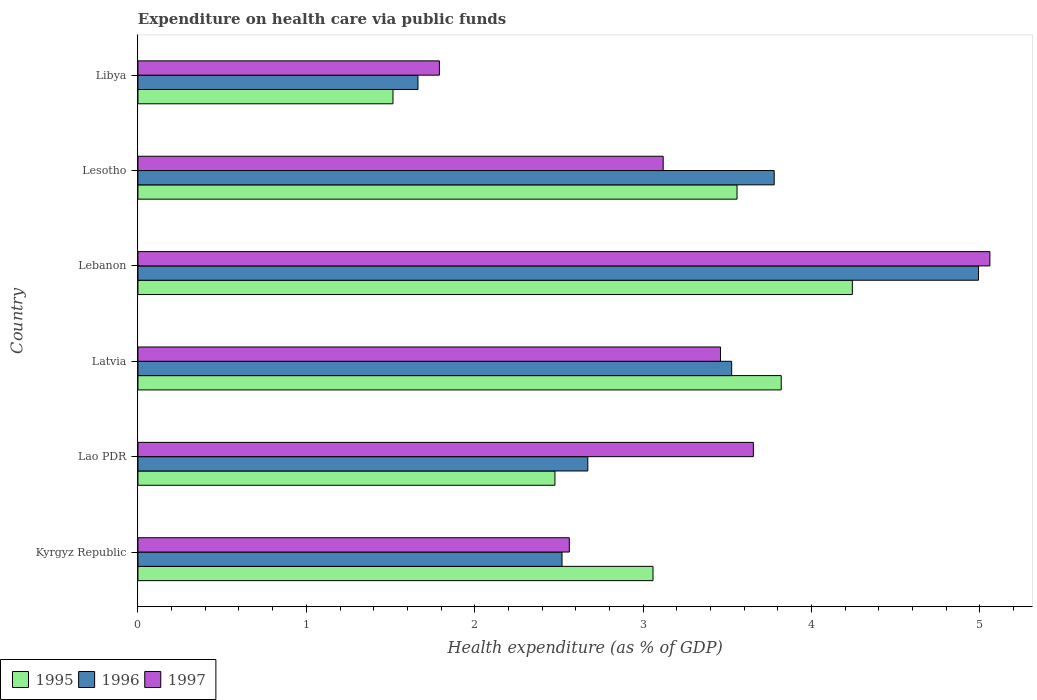How many groups of bars are there?
Offer a very short reply. 6. How many bars are there on the 3rd tick from the bottom?
Give a very brief answer. 3. What is the label of the 4th group of bars from the top?
Make the answer very short. Latvia. What is the expenditure made on health care in 1997 in Kyrgyz Republic?
Keep it short and to the point. 2.56. Across all countries, what is the maximum expenditure made on health care in 1997?
Keep it short and to the point. 5.06. Across all countries, what is the minimum expenditure made on health care in 1997?
Offer a terse response. 1.79. In which country was the expenditure made on health care in 1996 maximum?
Give a very brief answer. Lebanon. In which country was the expenditure made on health care in 1996 minimum?
Your answer should be compact. Libya. What is the total expenditure made on health care in 1995 in the graph?
Keep it short and to the point. 18.67. What is the difference between the expenditure made on health care in 1996 in Lao PDR and that in Latvia?
Your response must be concise. -0.85. What is the difference between the expenditure made on health care in 1997 in Lesotho and the expenditure made on health care in 1995 in Lebanon?
Provide a short and direct response. -1.12. What is the average expenditure made on health care in 1996 per country?
Keep it short and to the point. 3.19. What is the difference between the expenditure made on health care in 1995 and expenditure made on health care in 1996 in Lao PDR?
Offer a very short reply. -0.2. What is the ratio of the expenditure made on health care in 1997 in Kyrgyz Republic to that in Lesotho?
Keep it short and to the point. 0.82. Is the expenditure made on health care in 1997 in Lao PDR less than that in Lesotho?
Your answer should be compact. No. What is the difference between the highest and the second highest expenditure made on health care in 1997?
Ensure brevity in your answer.  1.4. What is the difference between the highest and the lowest expenditure made on health care in 1997?
Give a very brief answer. 3.27. In how many countries, is the expenditure made on health care in 1995 greater than the average expenditure made on health care in 1995 taken over all countries?
Offer a very short reply. 3. What does the 3rd bar from the top in Latvia represents?
Your answer should be very brief. 1995. What does the 1st bar from the bottom in Lebanon represents?
Your answer should be compact. 1995. Is it the case that in every country, the sum of the expenditure made on health care in 1995 and expenditure made on health care in 1997 is greater than the expenditure made on health care in 1996?
Your answer should be very brief. Yes. Are all the bars in the graph horizontal?
Make the answer very short. Yes. How many countries are there in the graph?
Keep it short and to the point. 6. Does the graph contain any zero values?
Your answer should be compact. No. Does the graph contain grids?
Your answer should be compact. No. How many legend labels are there?
Your answer should be compact. 3. How are the legend labels stacked?
Provide a succinct answer. Horizontal. What is the title of the graph?
Give a very brief answer. Expenditure on health care via public funds. What is the label or title of the X-axis?
Make the answer very short. Health expenditure (as % of GDP). What is the Health expenditure (as % of GDP) of 1995 in Kyrgyz Republic?
Keep it short and to the point. 3.06. What is the Health expenditure (as % of GDP) of 1996 in Kyrgyz Republic?
Your answer should be compact. 2.52. What is the Health expenditure (as % of GDP) of 1997 in Kyrgyz Republic?
Offer a very short reply. 2.56. What is the Health expenditure (as % of GDP) in 1995 in Lao PDR?
Offer a very short reply. 2.48. What is the Health expenditure (as % of GDP) in 1996 in Lao PDR?
Your answer should be compact. 2.67. What is the Health expenditure (as % of GDP) in 1997 in Lao PDR?
Offer a terse response. 3.65. What is the Health expenditure (as % of GDP) of 1995 in Latvia?
Offer a terse response. 3.82. What is the Health expenditure (as % of GDP) in 1996 in Latvia?
Give a very brief answer. 3.53. What is the Health expenditure (as % of GDP) in 1997 in Latvia?
Your response must be concise. 3.46. What is the Health expenditure (as % of GDP) of 1995 in Lebanon?
Your answer should be very brief. 4.24. What is the Health expenditure (as % of GDP) in 1996 in Lebanon?
Keep it short and to the point. 4.99. What is the Health expenditure (as % of GDP) in 1997 in Lebanon?
Make the answer very short. 5.06. What is the Health expenditure (as % of GDP) in 1995 in Lesotho?
Make the answer very short. 3.56. What is the Health expenditure (as % of GDP) of 1996 in Lesotho?
Give a very brief answer. 3.78. What is the Health expenditure (as % of GDP) in 1997 in Lesotho?
Keep it short and to the point. 3.12. What is the Health expenditure (as % of GDP) of 1995 in Libya?
Offer a terse response. 1.51. What is the Health expenditure (as % of GDP) of 1996 in Libya?
Keep it short and to the point. 1.66. What is the Health expenditure (as % of GDP) of 1997 in Libya?
Provide a short and direct response. 1.79. Across all countries, what is the maximum Health expenditure (as % of GDP) in 1995?
Your answer should be compact. 4.24. Across all countries, what is the maximum Health expenditure (as % of GDP) of 1996?
Your answer should be compact. 4.99. Across all countries, what is the maximum Health expenditure (as % of GDP) of 1997?
Provide a short and direct response. 5.06. Across all countries, what is the minimum Health expenditure (as % of GDP) of 1995?
Ensure brevity in your answer.  1.51. Across all countries, what is the minimum Health expenditure (as % of GDP) of 1996?
Make the answer very short. 1.66. Across all countries, what is the minimum Health expenditure (as % of GDP) in 1997?
Provide a succinct answer. 1.79. What is the total Health expenditure (as % of GDP) of 1995 in the graph?
Offer a terse response. 18.67. What is the total Health expenditure (as % of GDP) of 1996 in the graph?
Make the answer very short. 19.15. What is the total Health expenditure (as % of GDP) of 1997 in the graph?
Ensure brevity in your answer.  19.64. What is the difference between the Health expenditure (as % of GDP) in 1995 in Kyrgyz Republic and that in Lao PDR?
Offer a terse response. 0.58. What is the difference between the Health expenditure (as % of GDP) of 1996 in Kyrgyz Republic and that in Lao PDR?
Provide a succinct answer. -0.15. What is the difference between the Health expenditure (as % of GDP) of 1997 in Kyrgyz Republic and that in Lao PDR?
Your answer should be compact. -1.09. What is the difference between the Health expenditure (as % of GDP) of 1995 in Kyrgyz Republic and that in Latvia?
Offer a very short reply. -0.76. What is the difference between the Health expenditure (as % of GDP) in 1996 in Kyrgyz Republic and that in Latvia?
Offer a terse response. -1.01. What is the difference between the Health expenditure (as % of GDP) in 1997 in Kyrgyz Republic and that in Latvia?
Offer a very short reply. -0.9. What is the difference between the Health expenditure (as % of GDP) in 1995 in Kyrgyz Republic and that in Lebanon?
Your response must be concise. -1.18. What is the difference between the Health expenditure (as % of GDP) of 1996 in Kyrgyz Republic and that in Lebanon?
Provide a short and direct response. -2.47. What is the difference between the Health expenditure (as % of GDP) of 1997 in Kyrgyz Republic and that in Lebanon?
Your answer should be very brief. -2.5. What is the difference between the Health expenditure (as % of GDP) of 1995 in Kyrgyz Republic and that in Lesotho?
Offer a terse response. -0.5. What is the difference between the Health expenditure (as % of GDP) of 1996 in Kyrgyz Republic and that in Lesotho?
Keep it short and to the point. -1.26. What is the difference between the Health expenditure (as % of GDP) in 1997 in Kyrgyz Republic and that in Lesotho?
Keep it short and to the point. -0.56. What is the difference between the Health expenditure (as % of GDP) of 1995 in Kyrgyz Republic and that in Libya?
Make the answer very short. 1.54. What is the difference between the Health expenditure (as % of GDP) of 1996 in Kyrgyz Republic and that in Libya?
Your answer should be very brief. 0.86. What is the difference between the Health expenditure (as % of GDP) in 1997 in Kyrgyz Republic and that in Libya?
Offer a very short reply. 0.77. What is the difference between the Health expenditure (as % of GDP) in 1995 in Lao PDR and that in Latvia?
Ensure brevity in your answer.  -1.34. What is the difference between the Health expenditure (as % of GDP) of 1996 in Lao PDR and that in Latvia?
Offer a very short reply. -0.85. What is the difference between the Health expenditure (as % of GDP) in 1997 in Lao PDR and that in Latvia?
Keep it short and to the point. 0.2. What is the difference between the Health expenditure (as % of GDP) of 1995 in Lao PDR and that in Lebanon?
Provide a short and direct response. -1.77. What is the difference between the Health expenditure (as % of GDP) of 1996 in Lao PDR and that in Lebanon?
Your answer should be very brief. -2.32. What is the difference between the Health expenditure (as % of GDP) of 1997 in Lao PDR and that in Lebanon?
Your response must be concise. -1.4. What is the difference between the Health expenditure (as % of GDP) in 1995 in Lao PDR and that in Lesotho?
Provide a short and direct response. -1.08. What is the difference between the Health expenditure (as % of GDP) in 1996 in Lao PDR and that in Lesotho?
Your response must be concise. -1.11. What is the difference between the Health expenditure (as % of GDP) in 1997 in Lao PDR and that in Lesotho?
Offer a terse response. 0.54. What is the difference between the Health expenditure (as % of GDP) of 1995 in Lao PDR and that in Libya?
Your answer should be very brief. 0.96. What is the difference between the Health expenditure (as % of GDP) in 1996 in Lao PDR and that in Libya?
Provide a short and direct response. 1.01. What is the difference between the Health expenditure (as % of GDP) of 1997 in Lao PDR and that in Libya?
Offer a very short reply. 1.86. What is the difference between the Health expenditure (as % of GDP) of 1995 in Latvia and that in Lebanon?
Your answer should be very brief. -0.42. What is the difference between the Health expenditure (as % of GDP) of 1996 in Latvia and that in Lebanon?
Your response must be concise. -1.47. What is the difference between the Health expenditure (as % of GDP) of 1997 in Latvia and that in Lebanon?
Make the answer very short. -1.6. What is the difference between the Health expenditure (as % of GDP) in 1995 in Latvia and that in Lesotho?
Offer a terse response. 0.26. What is the difference between the Health expenditure (as % of GDP) in 1996 in Latvia and that in Lesotho?
Provide a short and direct response. -0.25. What is the difference between the Health expenditure (as % of GDP) in 1997 in Latvia and that in Lesotho?
Keep it short and to the point. 0.34. What is the difference between the Health expenditure (as % of GDP) in 1995 in Latvia and that in Libya?
Provide a short and direct response. 2.31. What is the difference between the Health expenditure (as % of GDP) of 1996 in Latvia and that in Libya?
Your response must be concise. 1.86. What is the difference between the Health expenditure (as % of GDP) in 1997 in Latvia and that in Libya?
Provide a succinct answer. 1.67. What is the difference between the Health expenditure (as % of GDP) of 1995 in Lebanon and that in Lesotho?
Make the answer very short. 0.68. What is the difference between the Health expenditure (as % of GDP) of 1996 in Lebanon and that in Lesotho?
Make the answer very short. 1.21. What is the difference between the Health expenditure (as % of GDP) in 1997 in Lebanon and that in Lesotho?
Your answer should be very brief. 1.94. What is the difference between the Health expenditure (as % of GDP) of 1995 in Lebanon and that in Libya?
Your response must be concise. 2.73. What is the difference between the Health expenditure (as % of GDP) in 1996 in Lebanon and that in Libya?
Your answer should be compact. 3.33. What is the difference between the Health expenditure (as % of GDP) of 1997 in Lebanon and that in Libya?
Make the answer very short. 3.27. What is the difference between the Health expenditure (as % of GDP) of 1995 in Lesotho and that in Libya?
Offer a terse response. 2.04. What is the difference between the Health expenditure (as % of GDP) in 1996 in Lesotho and that in Libya?
Ensure brevity in your answer.  2.12. What is the difference between the Health expenditure (as % of GDP) of 1997 in Lesotho and that in Libya?
Ensure brevity in your answer.  1.33. What is the difference between the Health expenditure (as % of GDP) of 1995 in Kyrgyz Republic and the Health expenditure (as % of GDP) of 1996 in Lao PDR?
Offer a very short reply. 0.39. What is the difference between the Health expenditure (as % of GDP) of 1995 in Kyrgyz Republic and the Health expenditure (as % of GDP) of 1997 in Lao PDR?
Your answer should be compact. -0.6. What is the difference between the Health expenditure (as % of GDP) of 1996 in Kyrgyz Republic and the Health expenditure (as % of GDP) of 1997 in Lao PDR?
Ensure brevity in your answer.  -1.14. What is the difference between the Health expenditure (as % of GDP) in 1995 in Kyrgyz Republic and the Health expenditure (as % of GDP) in 1996 in Latvia?
Give a very brief answer. -0.47. What is the difference between the Health expenditure (as % of GDP) of 1995 in Kyrgyz Republic and the Health expenditure (as % of GDP) of 1997 in Latvia?
Your answer should be very brief. -0.4. What is the difference between the Health expenditure (as % of GDP) in 1996 in Kyrgyz Republic and the Health expenditure (as % of GDP) in 1997 in Latvia?
Provide a short and direct response. -0.94. What is the difference between the Health expenditure (as % of GDP) of 1995 in Kyrgyz Republic and the Health expenditure (as % of GDP) of 1996 in Lebanon?
Make the answer very short. -1.93. What is the difference between the Health expenditure (as % of GDP) of 1995 in Kyrgyz Republic and the Health expenditure (as % of GDP) of 1997 in Lebanon?
Your answer should be compact. -2. What is the difference between the Health expenditure (as % of GDP) in 1996 in Kyrgyz Republic and the Health expenditure (as % of GDP) in 1997 in Lebanon?
Provide a short and direct response. -2.54. What is the difference between the Health expenditure (as % of GDP) of 1995 in Kyrgyz Republic and the Health expenditure (as % of GDP) of 1996 in Lesotho?
Your answer should be compact. -0.72. What is the difference between the Health expenditure (as % of GDP) of 1995 in Kyrgyz Republic and the Health expenditure (as % of GDP) of 1997 in Lesotho?
Provide a succinct answer. -0.06. What is the difference between the Health expenditure (as % of GDP) in 1996 in Kyrgyz Republic and the Health expenditure (as % of GDP) in 1997 in Lesotho?
Your answer should be compact. -0.6. What is the difference between the Health expenditure (as % of GDP) of 1995 in Kyrgyz Republic and the Health expenditure (as % of GDP) of 1996 in Libya?
Your answer should be compact. 1.4. What is the difference between the Health expenditure (as % of GDP) in 1995 in Kyrgyz Republic and the Health expenditure (as % of GDP) in 1997 in Libya?
Keep it short and to the point. 1.27. What is the difference between the Health expenditure (as % of GDP) of 1996 in Kyrgyz Republic and the Health expenditure (as % of GDP) of 1997 in Libya?
Make the answer very short. 0.73. What is the difference between the Health expenditure (as % of GDP) of 1995 in Lao PDR and the Health expenditure (as % of GDP) of 1996 in Latvia?
Your answer should be very brief. -1.05. What is the difference between the Health expenditure (as % of GDP) in 1995 in Lao PDR and the Health expenditure (as % of GDP) in 1997 in Latvia?
Ensure brevity in your answer.  -0.98. What is the difference between the Health expenditure (as % of GDP) in 1996 in Lao PDR and the Health expenditure (as % of GDP) in 1997 in Latvia?
Provide a short and direct response. -0.79. What is the difference between the Health expenditure (as % of GDP) of 1995 in Lao PDR and the Health expenditure (as % of GDP) of 1996 in Lebanon?
Give a very brief answer. -2.52. What is the difference between the Health expenditure (as % of GDP) of 1995 in Lao PDR and the Health expenditure (as % of GDP) of 1997 in Lebanon?
Ensure brevity in your answer.  -2.58. What is the difference between the Health expenditure (as % of GDP) of 1996 in Lao PDR and the Health expenditure (as % of GDP) of 1997 in Lebanon?
Ensure brevity in your answer.  -2.39. What is the difference between the Health expenditure (as % of GDP) in 1995 in Lao PDR and the Health expenditure (as % of GDP) in 1996 in Lesotho?
Offer a terse response. -1.3. What is the difference between the Health expenditure (as % of GDP) in 1995 in Lao PDR and the Health expenditure (as % of GDP) in 1997 in Lesotho?
Ensure brevity in your answer.  -0.64. What is the difference between the Health expenditure (as % of GDP) of 1996 in Lao PDR and the Health expenditure (as % of GDP) of 1997 in Lesotho?
Make the answer very short. -0.45. What is the difference between the Health expenditure (as % of GDP) in 1995 in Lao PDR and the Health expenditure (as % of GDP) in 1996 in Libya?
Make the answer very short. 0.81. What is the difference between the Health expenditure (as % of GDP) in 1995 in Lao PDR and the Health expenditure (as % of GDP) in 1997 in Libya?
Your answer should be very brief. 0.69. What is the difference between the Health expenditure (as % of GDP) in 1996 in Lao PDR and the Health expenditure (as % of GDP) in 1997 in Libya?
Your answer should be compact. 0.88. What is the difference between the Health expenditure (as % of GDP) in 1995 in Latvia and the Health expenditure (as % of GDP) in 1996 in Lebanon?
Your answer should be compact. -1.17. What is the difference between the Health expenditure (as % of GDP) of 1995 in Latvia and the Health expenditure (as % of GDP) of 1997 in Lebanon?
Your response must be concise. -1.24. What is the difference between the Health expenditure (as % of GDP) in 1996 in Latvia and the Health expenditure (as % of GDP) in 1997 in Lebanon?
Keep it short and to the point. -1.53. What is the difference between the Health expenditure (as % of GDP) in 1995 in Latvia and the Health expenditure (as % of GDP) in 1996 in Lesotho?
Your answer should be very brief. 0.04. What is the difference between the Health expenditure (as % of GDP) of 1995 in Latvia and the Health expenditure (as % of GDP) of 1997 in Lesotho?
Ensure brevity in your answer.  0.7. What is the difference between the Health expenditure (as % of GDP) in 1996 in Latvia and the Health expenditure (as % of GDP) in 1997 in Lesotho?
Your response must be concise. 0.41. What is the difference between the Health expenditure (as % of GDP) in 1995 in Latvia and the Health expenditure (as % of GDP) in 1996 in Libya?
Offer a terse response. 2.16. What is the difference between the Health expenditure (as % of GDP) in 1995 in Latvia and the Health expenditure (as % of GDP) in 1997 in Libya?
Your answer should be very brief. 2.03. What is the difference between the Health expenditure (as % of GDP) of 1996 in Latvia and the Health expenditure (as % of GDP) of 1997 in Libya?
Your answer should be very brief. 1.74. What is the difference between the Health expenditure (as % of GDP) of 1995 in Lebanon and the Health expenditure (as % of GDP) of 1996 in Lesotho?
Provide a succinct answer. 0.46. What is the difference between the Health expenditure (as % of GDP) of 1995 in Lebanon and the Health expenditure (as % of GDP) of 1997 in Lesotho?
Your answer should be compact. 1.12. What is the difference between the Health expenditure (as % of GDP) of 1996 in Lebanon and the Health expenditure (as % of GDP) of 1997 in Lesotho?
Make the answer very short. 1.87. What is the difference between the Health expenditure (as % of GDP) in 1995 in Lebanon and the Health expenditure (as % of GDP) in 1996 in Libya?
Offer a terse response. 2.58. What is the difference between the Health expenditure (as % of GDP) in 1995 in Lebanon and the Health expenditure (as % of GDP) in 1997 in Libya?
Offer a terse response. 2.45. What is the difference between the Health expenditure (as % of GDP) of 1996 in Lebanon and the Health expenditure (as % of GDP) of 1997 in Libya?
Give a very brief answer. 3.2. What is the difference between the Health expenditure (as % of GDP) in 1995 in Lesotho and the Health expenditure (as % of GDP) in 1996 in Libya?
Your answer should be compact. 1.9. What is the difference between the Health expenditure (as % of GDP) of 1995 in Lesotho and the Health expenditure (as % of GDP) of 1997 in Libya?
Provide a succinct answer. 1.77. What is the difference between the Health expenditure (as % of GDP) in 1996 in Lesotho and the Health expenditure (as % of GDP) in 1997 in Libya?
Your response must be concise. 1.99. What is the average Health expenditure (as % of GDP) in 1995 per country?
Your answer should be very brief. 3.11. What is the average Health expenditure (as % of GDP) in 1996 per country?
Your answer should be compact. 3.19. What is the average Health expenditure (as % of GDP) of 1997 per country?
Keep it short and to the point. 3.27. What is the difference between the Health expenditure (as % of GDP) in 1995 and Health expenditure (as % of GDP) in 1996 in Kyrgyz Republic?
Your response must be concise. 0.54. What is the difference between the Health expenditure (as % of GDP) of 1995 and Health expenditure (as % of GDP) of 1997 in Kyrgyz Republic?
Offer a very short reply. 0.5. What is the difference between the Health expenditure (as % of GDP) of 1996 and Health expenditure (as % of GDP) of 1997 in Kyrgyz Republic?
Your answer should be very brief. -0.04. What is the difference between the Health expenditure (as % of GDP) in 1995 and Health expenditure (as % of GDP) in 1996 in Lao PDR?
Your response must be concise. -0.2. What is the difference between the Health expenditure (as % of GDP) in 1995 and Health expenditure (as % of GDP) in 1997 in Lao PDR?
Offer a terse response. -1.18. What is the difference between the Health expenditure (as % of GDP) in 1996 and Health expenditure (as % of GDP) in 1997 in Lao PDR?
Give a very brief answer. -0.98. What is the difference between the Health expenditure (as % of GDP) in 1995 and Health expenditure (as % of GDP) in 1996 in Latvia?
Your answer should be compact. 0.29. What is the difference between the Health expenditure (as % of GDP) of 1995 and Health expenditure (as % of GDP) of 1997 in Latvia?
Provide a succinct answer. 0.36. What is the difference between the Health expenditure (as % of GDP) in 1996 and Health expenditure (as % of GDP) in 1997 in Latvia?
Your answer should be compact. 0.07. What is the difference between the Health expenditure (as % of GDP) in 1995 and Health expenditure (as % of GDP) in 1996 in Lebanon?
Your response must be concise. -0.75. What is the difference between the Health expenditure (as % of GDP) of 1995 and Health expenditure (as % of GDP) of 1997 in Lebanon?
Give a very brief answer. -0.82. What is the difference between the Health expenditure (as % of GDP) in 1996 and Health expenditure (as % of GDP) in 1997 in Lebanon?
Ensure brevity in your answer.  -0.07. What is the difference between the Health expenditure (as % of GDP) of 1995 and Health expenditure (as % of GDP) of 1996 in Lesotho?
Your answer should be compact. -0.22. What is the difference between the Health expenditure (as % of GDP) of 1995 and Health expenditure (as % of GDP) of 1997 in Lesotho?
Provide a succinct answer. 0.44. What is the difference between the Health expenditure (as % of GDP) in 1996 and Health expenditure (as % of GDP) in 1997 in Lesotho?
Provide a short and direct response. 0.66. What is the difference between the Health expenditure (as % of GDP) of 1995 and Health expenditure (as % of GDP) of 1996 in Libya?
Provide a short and direct response. -0.15. What is the difference between the Health expenditure (as % of GDP) of 1995 and Health expenditure (as % of GDP) of 1997 in Libya?
Offer a terse response. -0.28. What is the difference between the Health expenditure (as % of GDP) of 1996 and Health expenditure (as % of GDP) of 1997 in Libya?
Provide a succinct answer. -0.13. What is the ratio of the Health expenditure (as % of GDP) in 1995 in Kyrgyz Republic to that in Lao PDR?
Your response must be concise. 1.24. What is the ratio of the Health expenditure (as % of GDP) in 1996 in Kyrgyz Republic to that in Lao PDR?
Your answer should be compact. 0.94. What is the ratio of the Health expenditure (as % of GDP) in 1997 in Kyrgyz Republic to that in Lao PDR?
Ensure brevity in your answer.  0.7. What is the ratio of the Health expenditure (as % of GDP) in 1995 in Kyrgyz Republic to that in Latvia?
Ensure brevity in your answer.  0.8. What is the ratio of the Health expenditure (as % of GDP) in 1996 in Kyrgyz Republic to that in Latvia?
Your answer should be compact. 0.71. What is the ratio of the Health expenditure (as % of GDP) of 1997 in Kyrgyz Republic to that in Latvia?
Make the answer very short. 0.74. What is the ratio of the Health expenditure (as % of GDP) in 1995 in Kyrgyz Republic to that in Lebanon?
Your answer should be compact. 0.72. What is the ratio of the Health expenditure (as % of GDP) of 1996 in Kyrgyz Republic to that in Lebanon?
Your response must be concise. 0.5. What is the ratio of the Health expenditure (as % of GDP) in 1997 in Kyrgyz Republic to that in Lebanon?
Give a very brief answer. 0.51. What is the ratio of the Health expenditure (as % of GDP) of 1995 in Kyrgyz Republic to that in Lesotho?
Provide a short and direct response. 0.86. What is the ratio of the Health expenditure (as % of GDP) of 1996 in Kyrgyz Republic to that in Lesotho?
Offer a very short reply. 0.67. What is the ratio of the Health expenditure (as % of GDP) in 1997 in Kyrgyz Republic to that in Lesotho?
Your response must be concise. 0.82. What is the ratio of the Health expenditure (as % of GDP) of 1995 in Kyrgyz Republic to that in Libya?
Your answer should be compact. 2.02. What is the ratio of the Health expenditure (as % of GDP) of 1996 in Kyrgyz Republic to that in Libya?
Your answer should be very brief. 1.51. What is the ratio of the Health expenditure (as % of GDP) of 1997 in Kyrgyz Republic to that in Libya?
Offer a very short reply. 1.43. What is the ratio of the Health expenditure (as % of GDP) in 1995 in Lao PDR to that in Latvia?
Your answer should be very brief. 0.65. What is the ratio of the Health expenditure (as % of GDP) of 1996 in Lao PDR to that in Latvia?
Your answer should be very brief. 0.76. What is the ratio of the Health expenditure (as % of GDP) in 1997 in Lao PDR to that in Latvia?
Offer a terse response. 1.06. What is the ratio of the Health expenditure (as % of GDP) in 1995 in Lao PDR to that in Lebanon?
Offer a very short reply. 0.58. What is the ratio of the Health expenditure (as % of GDP) in 1996 in Lao PDR to that in Lebanon?
Your answer should be very brief. 0.54. What is the ratio of the Health expenditure (as % of GDP) in 1997 in Lao PDR to that in Lebanon?
Your response must be concise. 0.72. What is the ratio of the Health expenditure (as % of GDP) in 1995 in Lao PDR to that in Lesotho?
Your answer should be very brief. 0.7. What is the ratio of the Health expenditure (as % of GDP) in 1996 in Lao PDR to that in Lesotho?
Your answer should be very brief. 0.71. What is the ratio of the Health expenditure (as % of GDP) in 1997 in Lao PDR to that in Lesotho?
Provide a short and direct response. 1.17. What is the ratio of the Health expenditure (as % of GDP) in 1995 in Lao PDR to that in Libya?
Keep it short and to the point. 1.64. What is the ratio of the Health expenditure (as % of GDP) of 1996 in Lao PDR to that in Libya?
Provide a succinct answer. 1.61. What is the ratio of the Health expenditure (as % of GDP) in 1997 in Lao PDR to that in Libya?
Provide a short and direct response. 2.04. What is the ratio of the Health expenditure (as % of GDP) in 1995 in Latvia to that in Lebanon?
Offer a very short reply. 0.9. What is the ratio of the Health expenditure (as % of GDP) of 1996 in Latvia to that in Lebanon?
Offer a very short reply. 0.71. What is the ratio of the Health expenditure (as % of GDP) in 1997 in Latvia to that in Lebanon?
Offer a terse response. 0.68. What is the ratio of the Health expenditure (as % of GDP) in 1995 in Latvia to that in Lesotho?
Your answer should be very brief. 1.07. What is the ratio of the Health expenditure (as % of GDP) of 1996 in Latvia to that in Lesotho?
Make the answer very short. 0.93. What is the ratio of the Health expenditure (as % of GDP) of 1997 in Latvia to that in Lesotho?
Keep it short and to the point. 1.11. What is the ratio of the Health expenditure (as % of GDP) in 1995 in Latvia to that in Libya?
Offer a terse response. 2.52. What is the ratio of the Health expenditure (as % of GDP) of 1996 in Latvia to that in Libya?
Your answer should be very brief. 2.12. What is the ratio of the Health expenditure (as % of GDP) in 1997 in Latvia to that in Libya?
Give a very brief answer. 1.93. What is the ratio of the Health expenditure (as % of GDP) in 1995 in Lebanon to that in Lesotho?
Your answer should be very brief. 1.19. What is the ratio of the Health expenditure (as % of GDP) in 1996 in Lebanon to that in Lesotho?
Give a very brief answer. 1.32. What is the ratio of the Health expenditure (as % of GDP) of 1997 in Lebanon to that in Lesotho?
Give a very brief answer. 1.62. What is the ratio of the Health expenditure (as % of GDP) in 1995 in Lebanon to that in Libya?
Your answer should be compact. 2.8. What is the ratio of the Health expenditure (as % of GDP) of 1996 in Lebanon to that in Libya?
Your answer should be compact. 3. What is the ratio of the Health expenditure (as % of GDP) in 1997 in Lebanon to that in Libya?
Your answer should be very brief. 2.83. What is the ratio of the Health expenditure (as % of GDP) of 1995 in Lesotho to that in Libya?
Give a very brief answer. 2.35. What is the ratio of the Health expenditure (as % of GDP) in 1996 in Lesotho to that in Libya?
Offer a very short reply. 2.27. What is the ratio of the Health expenditure (as % of GDP) in 1997 in Lesotho to that in Libya?
Offer a very short reply. 1.74. What is the difference between the highest and the second highest Health expenditure (as % of GDP) in 1995?
Provide a short and direct response. 0.42. What is the difference between the highest and the second highest Health expenditure (as % of GDP) of 1996?
Your answer should be compact. 1.21. What is the difference between the highest and the second highest Health expenditure (as % of GDP) of 1997?
Your answer should be compact. 1.4. What is the difference between the highest and the lowest Health expenditure (as % of GDP) of 1995?
Make the answer very short. 2.73. What is the difference between the highest and the lowest Health expenditure (as % of GDP) in 1996?
Ensure brevity in your answer.  3.33. What is the difference between the highest and the lowest Health expenditure (as % of GDP) of 1997?
Provide a succinct answer. 3.27. 